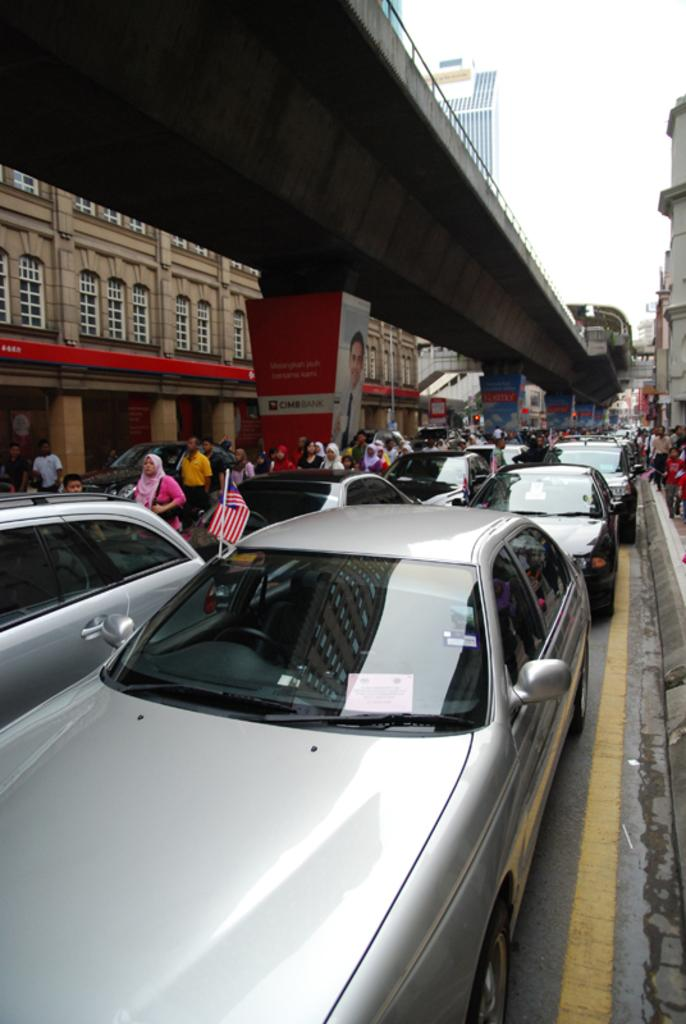What is happening to the vehicles in the image? The vehicles are stuck in traffic in the image. What structure can be seen in the image? There is a bridge in the image. What are the people in the image doing? There are people walking on the road in the image. What is the condition of the sky in the image? The sky is clear in the image. What type of reward can be seen hanging from the bridge in the image? There is no reward hanging from the bridge in the image; it is a structure for vehicles and pedestrians to cross. Can you tell me how many lawyers are visible in the image? There are no lawyers present in the image. 